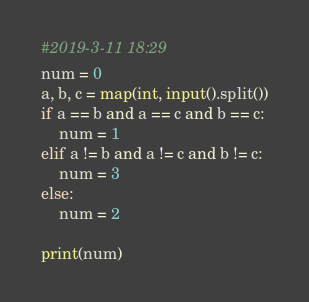Convert code to text. <code><loc_0><loc_0><loc_500><loc_500><_Python_>#2019-3-11 18:29
num = 0
a, b, c = map(int, input().split())
if a == b and a == c and b == c:
	num = 1
elif a != b and a != c and b != c:
	num = 3
else:
	num = 2

print(num)</code> 